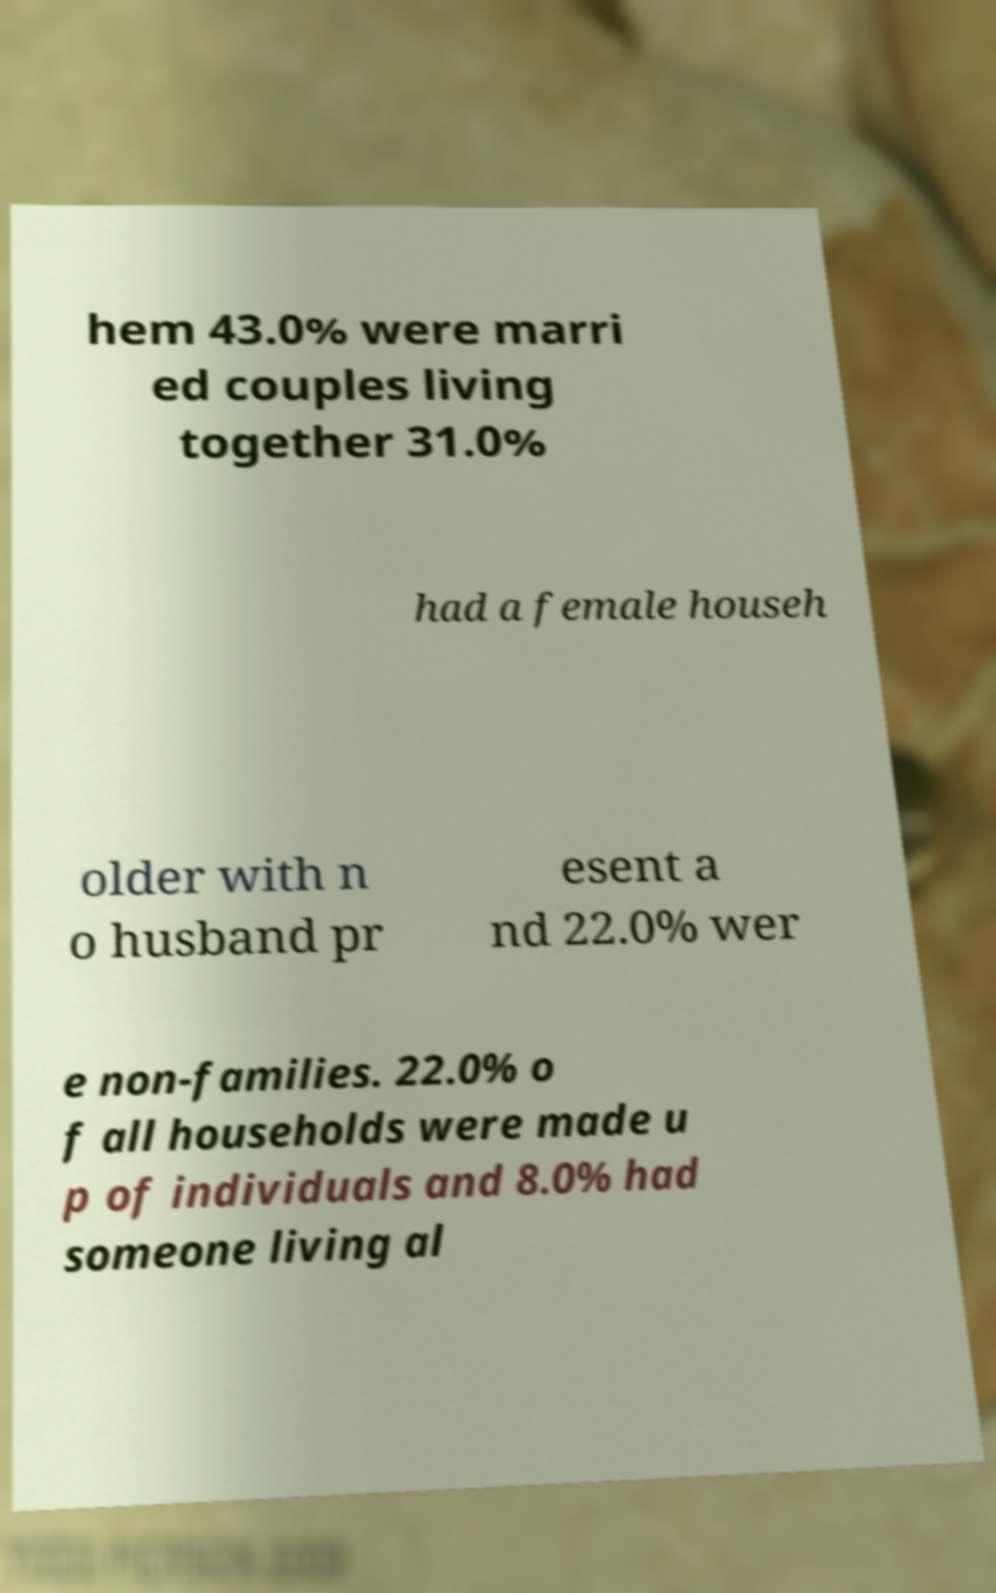I need the written content from this picture converted into text. Can you do that? hem 43.0% were marri ed couples living together 31.0% had a female househ older with n o husband pr esent a nd 22.0% wer e non-families. 22.0% o f all households were made u p of individuals and 8.0% had someone living al 